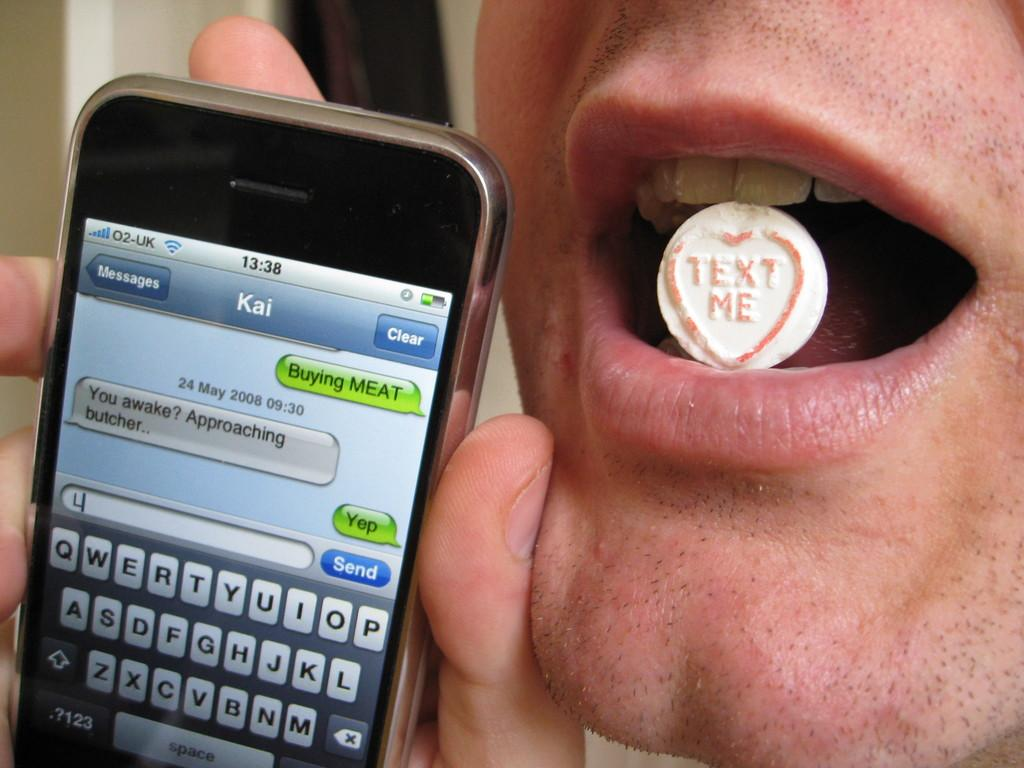<image>
Share a concise interpretation of the image provided. A man is holding a cell phone to his face and has placed a heart shaped token with the words text me in his mouth. 